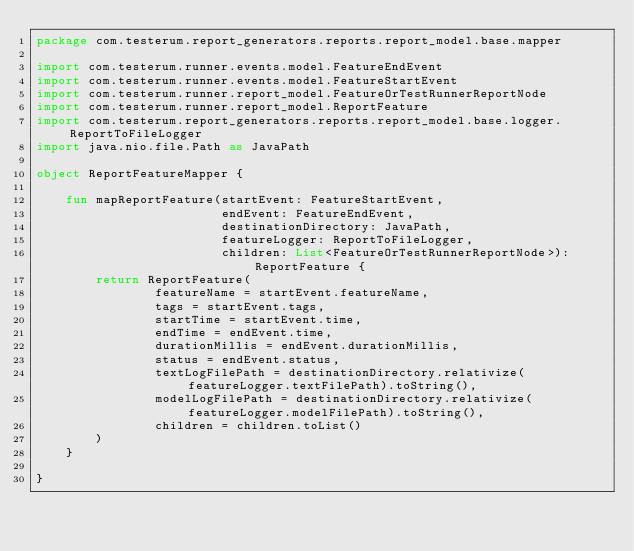<code> <loc_0><loc_0><loc_500><loc_500><_Kotlin_>package com.testerum.report_generators.reports.report_model.base.mapper

import com.testerum.runner.events.model.FeatureEndEvent
import com.testerum.runner.events.model.FeatureStartEvent
import com.testerum.runner.report_model.FeatureOrTestRunnerReportNode
import com.testerum.runner.report_model.ReportFeature
import com.testerum.report_generators.reports.report_model.base.logger.ReportToFileLogger
import java.nio.file.Path as JavaPath

object ReportFeatureMapper {

    fun mapReportFeature(startEvent: FeatureStartEvent,
                         endEvent: FeatureEndEvent,
                         destinationDirectory: JavaPath,
                         featureLogger: ReportToFileLogger,
                         children: List<FeatureOrTestRunnerReportNode>): ReportFeature {
        return ReportFeature(
                featureName = startEvent.featureName,
                tags = startEvent.tags,
                startTime = startEvent.time,
                endTime = endEvent.time,
                durationMillis = endEvent.durationMillis,
                status = endEvent.status,
                textLogFilePath = destinationDirectory.relativize(featureLogger.textFilePath).toString(),
                modelLogFilePath = destinationDirectory.relativize(featureLogger.modelFilePath).toString(),
                children = children.toList()
        )
    }

}
</code> 